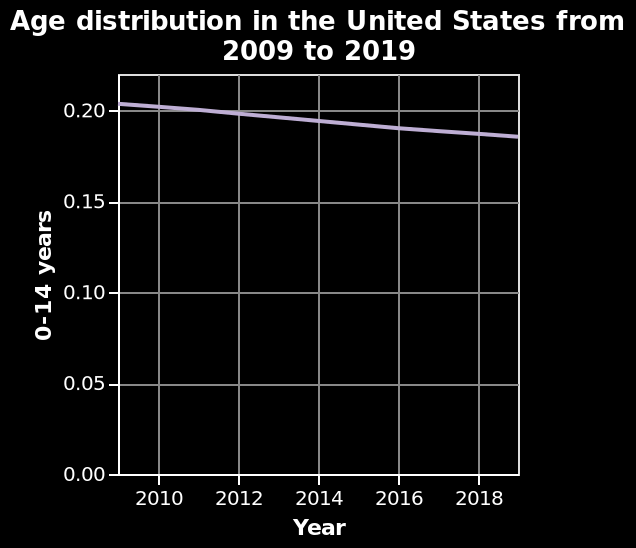<image>
Describe the following image in detail Here a line diagram is called Age distribution in the United States from 2009 to 2019. The x-axis plots Year while the y-axis plots 0-14 years. 